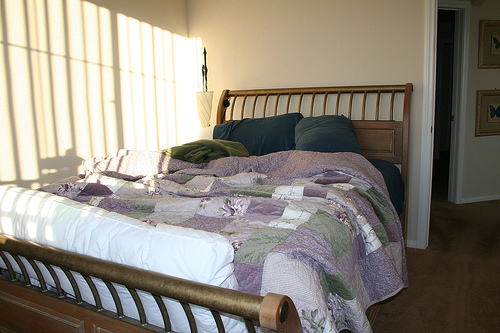<image>
Can you confirm if the picture is behind the bed? Yes. From this viewpoint, the picture is positioned behind the bed, with the bed partially or fully occluding the picture. 